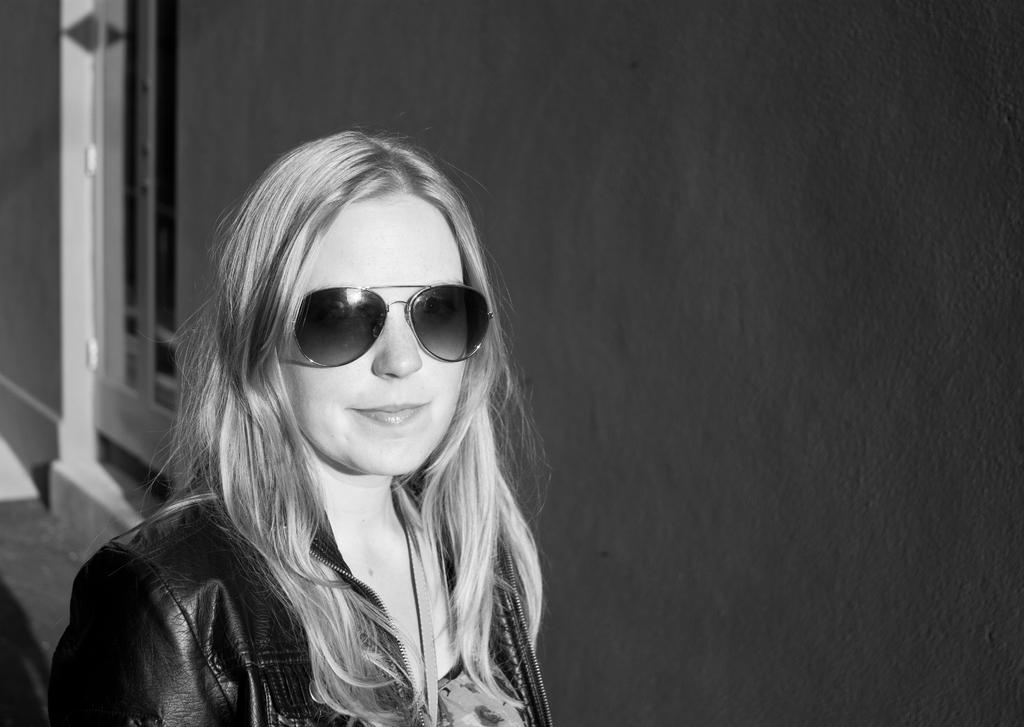What is the color scheme of the image? The image is black and white. Who is present in the image? There is a woman in the image. What can be seen in the background of the image? There is a wall in the background of the image. Can you describe the wall in the background? There is a window in the wall in the background of the image. What type of snail can be seen crawling on the woman's shoulder in the image? There is no snail present in the image; it is a black and white image of a woman with a wall and window in the background. 